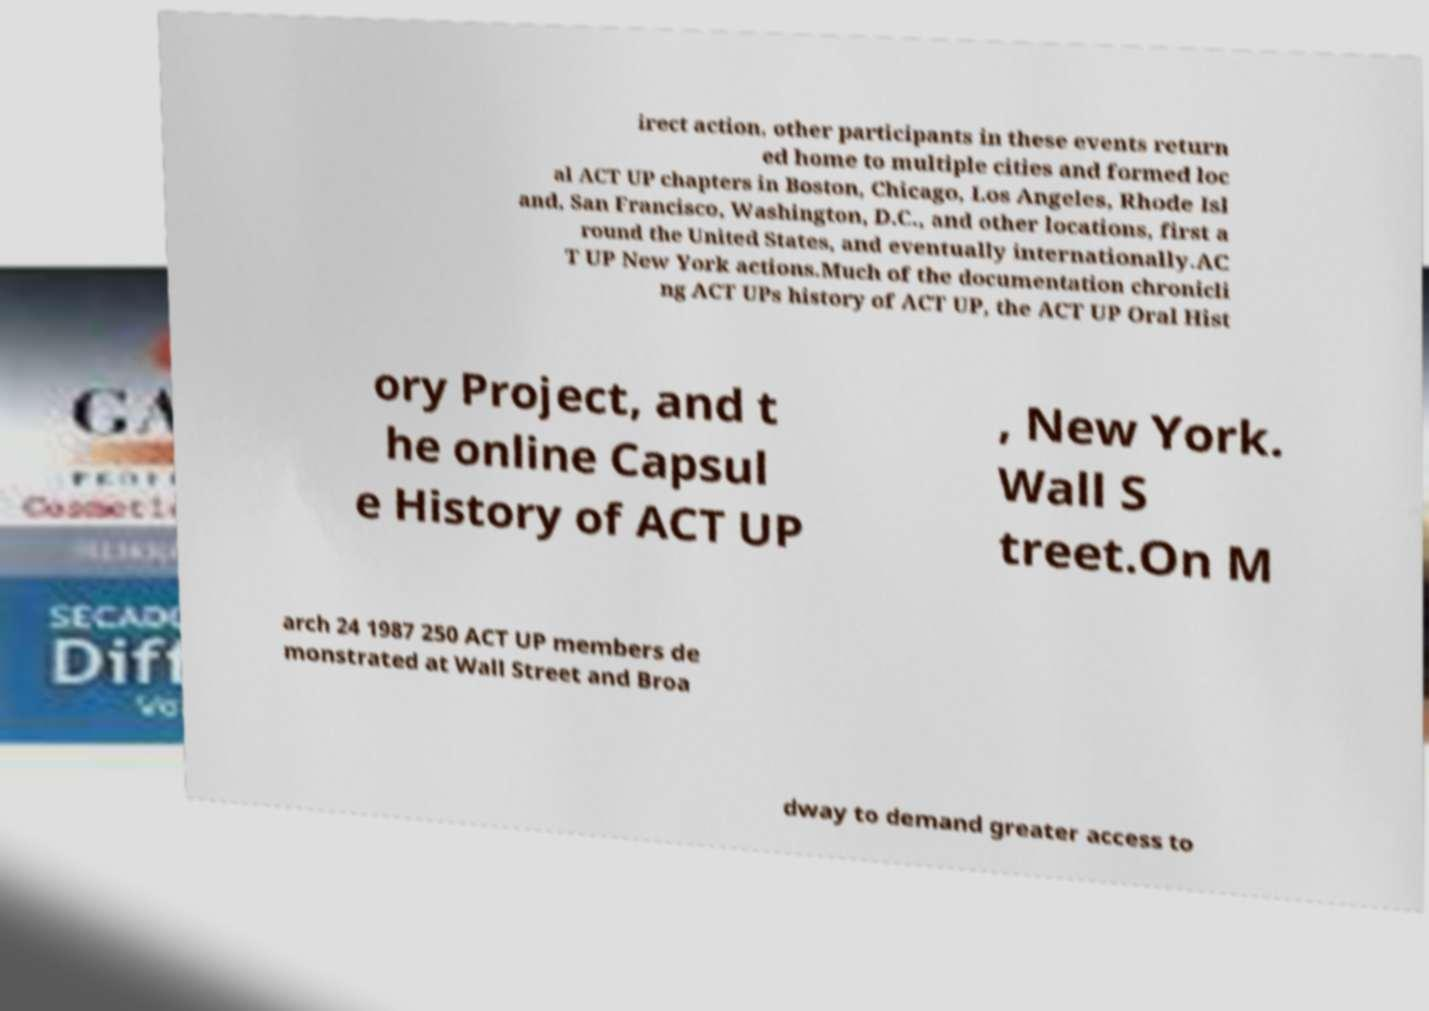Could you assist in decoding the text presented in this image and type it out clearly? irect action, other participants in these events return ed home to multiple cities and formed loc al ACT UP chapters in Boston, Chicago, Los Angeles, Rhode Isl and, San Francisco, Washington, D.C., and other locations, first a round the United States, and eventually internationally.AC T UP New York actions.Much of the documentation chronicli ng ACT UPs history of ACT UP, the ACT UP Oral Hist ory Project, and t he online Capsul e History of ACT UP , New York. Wall S treet.On M arch 24 1987 250 ACT UP members de monstrated at Wall Street and Broa dway to demand greater access to 